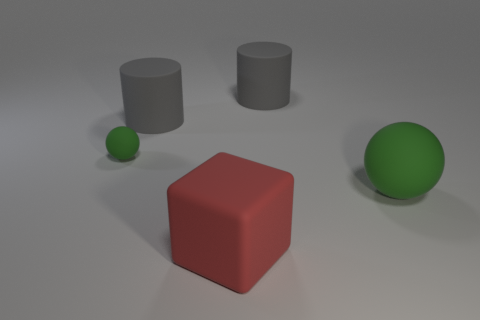Is the green thing right of the tiny green thing made of the same material as the gray cylinder to the left of the cube?
Provide a succinct answer. Yes. Are there an equal number of big rubber cubes left of the red object and large matte blocks behind the tiny object?
Your answer should be very brief. Yes. What color is the sphere that is the same size as the red matte object?
Your answer should be compact. Green. Are there any tiny cylinders of the same color as the rubber block?
Offer a terse response. No. How many objects are either green rubber balls that are left of the big green matte sphere or green rubber things?
Your response must be concise. 2. What number of other objects are there of the same size as the red thing?
Keep it short and to the point. 3. What is the material of the ball that is to the left of the big matte thing on the right side of the big gray object that is to the right of the big cube?
Ensure brevity in your answer.  Rubber. What number of blocks are either large gray matte objects or tiny matte things?
Offer a very short reply. 0. Is there any other thing that has the same shape as the small green object?
Offer a very short reply. Yes. Is the number of large green rubber balls that are in front of the big matte cube greater than the number of rubber cubes that are behind the large green sphere?
Keep it short and to the point. No. 